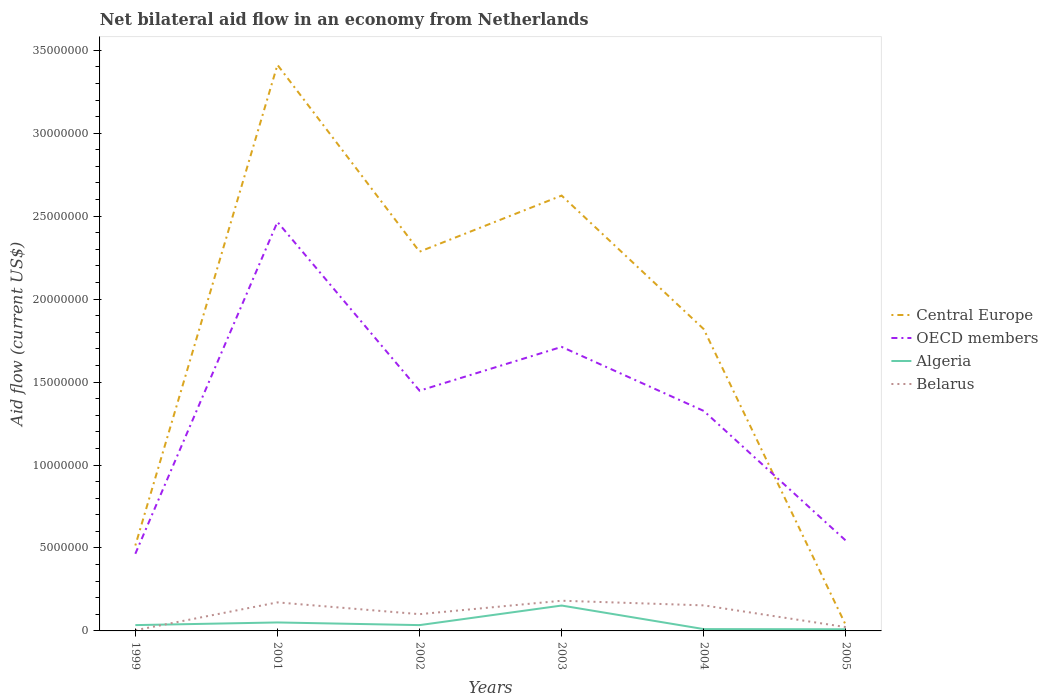How many different coloured lines are there?
Offer a terse response. 4. Does the line corresponding to Belarus intersect with the line corresponding to Algeria?
Ensure brevity in your answer.  Yes. What is the difference between the highest and the second highest net bilateral aid flow in OECD members?
Your answer should be very brief. 2.00e+07. What is the difference between the highest and the lowest net bilateral aid flow in Belarus?
Offer a very short reply. 3. How many lines are there?
Provide a short and direct response. 4. How many years are there in the graph?
Offer a terse response. 6. What is the difference between two consecutive major ticks on the Y-axis?
Offer a very short reply. 5.00e+06. Are the values on the major ticks of Y-axis written in scientific E-notation?
Make the answer very short. No. Does the graph contain any zero values?
Your response must be concise. No. Does the graph contain grids?
Your answer should be compact. No. How many legend labels are there?
Make the answer very short. 4. How are the legend labels stacked?
Keep it short and to the point. Vertical. What is the title of the graph?
Keep it short and to the point. Net bilateral aid flow in an economy from Netherlands. What is the Aid flow (current US$) in Central Europe in 1999?
Keep it short and to the point. 5.15e+06. What is the Aid flow (current US$) of OECD members in 1999?
Make the answer very short. 4.65e+06. What is the Aid flow (current US$) of Belarus in 1999?
Make the answer very short. 4.00e+04. What is the Aid flow (current US$) in Central Europe in 2001?
Your answer should be compact. 3.41e+07. What is the Aid flow (current US$) in OECD members in 2001?
Keep it short and to the point. 2.46e+07. What is the Aid flow (current US$) in Algeria in 2001?
Make the answer very short. 5.10e+05. What is the Aid flow (current US$) in Belarus in 2001?
Offer a terse response. 1.72e+06. What is the Aid flow (current US$) of Central Europe in 2002?
Offer a terse response. 2.29e+07. What is the Aid flow (current US$) in OECD members in 2002?
Your answer should be compact. 1.45e+07. What is the Aid flow (current US$) of Belarus in 2002?
Your answer should be compact. 1.01e+06. What is the Aid flow (current US$) of Central Europe in 2003?
Provide a short and direct response. 2.62e+07. What is the Aid flow (current US$) in OECD members in 2003?
Provide a succinct answer. 1.71e+07. What is the Aid flow (current US$) in Algeria in 2003?
Offer a terse response. 1.53e+06. What is the Aid flow (current US$) of Belarus in 2003?
Your answer should be compact. 1.82e+06. What is the Aid flow (current US$) in Central Europe in 2004?
Offer a very short reply. 1.82e+07. What is the Aid flow (current US$) in OECD members in 2004?
Offer a terse response. 1.33e+07. What is the Aid flow (current US$) of Belarus in 2004?
Ensure brevity in your answer.  1.54e+06. What is the Aid flow (current US$) in Central Europe in 2005?
Your answer should be compact. 3.40e+05. What is the Aid flow (current US$) of OECD members in 2005?
Your answer should be very brief. 5.44e+06. Across all years, what is the maximum Aid flow (current US$) in Central Europe?
Offer a very short reply. 3.41e+07. Across all years, what is the maximum Aid flow (current US$) in OECD members?
Offer a very short reply. 2.46e+07. Across all years, what is the maximum Aid flow (current US$) in Algeria?
Your response must be concise. 1.53e+06. Across all years, what is the maximum Aid flow (current US$) in Belarus?
Make the answer very short. 1.82e+06. Across all years, what is the minimum Aid flow (current US$) in OECD members?
Ensure brevity in your answer.  4.65e+06. Across all years, what is the minimum Aid flow (current US$) of Algeria?
Ensure brevity in your answer.  1.00e+05. Across all years, what is the minimum Aid flow (current US$) of Belarus?
Provide a succinct answer. 4.00e+04. What is the total Aid flow (current US$) in Central Europe in the graph?
Your response must be concise. 1.07e+08. What is the total Aid flow (current US$) of OECD members in the graph?
Offer a terse response. 7.96e+07. What is the total Aid flow (current US$) in Algeria in the graph?
Your answer should be compact. 2.95e+06. What is the total Aid flow (current US$) of Belarus in the graph?
Keep it short and to the point. 6.36e+06. What is the difference between the Aid flow (current US$) in Central Europe in 1999 and that in 2001?
Make the answer very short. -2.90e+07. What is the difference between the Aid flow (current US$) of OECD members in 1999 and that in 2001?
Offer a terse response. -2.00e+07. What is the difference between the Aid flow (current US$) of Belarus in 1999 and that in 2001?
Provide a short and direct response. -1.68e+06. What is the difference between the Aid flow (current US$) of Central Europe in 1999 and that in 2002?
Give a very brief answer. -1.77e+07. What is the difference between the Aid flow (current US$) in OECD members in 1999 and that in 2002?
Your response must be concise. -9.83e+06. What is the difference between the Aid flow (current US$) of Algeria in 1999 and that in 2002?
Your response must be concise. 0. What is the difference between the Aid flow (current US$) of Belarus in 1999 and that in 2002?
Provide a succinct answer. -9.70e+05. What is the difference between the Aid flow (current US$) in Central Europe in 1999 and that in 2003?
Give a very brief answer. -2.11e+07. What is the difference between the Aid flow (current US$) of OECD members in 1999 and that in 2003?
Give a very brief answer. -1.25e+07. What is the difference between the Aid flow (current US$) in Algeria in 1999 and that in 2003?
Your answer should be very brief. -1.18e+06. What is the difference between the Aid flow (current US$) in Belarus in 1999 and that in 2003?
Your answer should be compact. -1.78e+06. What is the difference between the Aid flow (current US$) of Central Europe in 1999 and that in 2004?
Give a very brief answer. -1.30e+07. What is the difference between the Aid flow (current US$) of OECD members in 1999 and that in 2004?
Make the answer very short. -8.61e+06. What is the difference between the Aid flow (current US$) of Algeria in 1999 and that in 2004?
Offer a terse response. 2.40e+05. What is the difference between the Aid flow (current US$) in Belarus in 1999 and that in 2004?
Provide a succinct answer. -1.50e+06. What is the difference between the Aid flow (current US$) in Central Europe in 1999 and that in 2005?
Your answer should be compact. 4.81e+06. What is the difference between the Aid flow (current US$) in OECD members in 1999 and that in 2005?
Ensure brevity in your answer.  -7.90e+05. What is the difference between the Aid flow (current US$) in Central Europe in 2001 and that in 2002?
Offer a terse response. 1.13e+07. What is the difference between the Aid flow (current US$) in OECD members in 2001 and that in 2002?
Your answer should be compact. 1.02e+07. What is the difference between the Aid flow (current US$) in Belarus in 2001 and that in 2002?
Your answer should be very brief. 7.10e+05. What is the difference between the Aid flow (current US$) in Central Europe in 2001 and that in 2003?
Provide a short and direct response. 7.88e+06. What is the difference between the Aid flow (current US$) in OECD members in 2001 and that in 2003?
Offer a very short reply. 7.53e+06. What is the difference between the Aid flow (current US$) of Algeria in 2001 and that in 2003?
Make the answer very short. -1.02e+06. What is the difference between the Aid flow (current US$) in Central Europe in 2001 and that in 2004?
Your answer should be compact. 1.59e+07. What is the difference between the Aid flow (current US$) in OECD members in 2001 and that in 2004?
Your answer should be compact. 1.14e+07. What is the difference between the Aid flow (current US$) of Algeria in 2001 and that in 2004?
Make the answer very short. 4.00e+05. What is the difference between the Aid flow (current US$) of Belarus in 2001 and that in 2004?
Your answer should be very brief. 1.80e+05. What is the difference between the Aid flow (current US$) in Central Europe in 2001 and that in 2005?
Offer a very short reply. 3.38e+07. What is the difference between the Aid flow (current US$) in OECD members in 2001 and that in 2005?
Offer a terse response. 1.92e+07. What is the difference between the Aid flow (current US$) of Algeria in 2001 and that in 2005?
Provide a short and direct response. 4.10e+05. What is the difference between the Aid flow (current US$) in Belarus in 2001 and that in 2005?
Give a very brief answer. 1.49e+06. What is the difference between the Aid flow (current US$) of Central Europe in 2002 and that in 2003?
Ensure brevity in your answer.  -3.38e+06. What is the difference between the Aid flow (current US$) of OECD members in 2002 and that in 2003?
Your answer should be very brief. -2.64e+06. What is the difference between the Aid flow (current US$) of Algeria in 2002 and that in 2003?
Your response must be concise. -1.18e+06. What is the difference between the Aid flow (current US$) of Belarus in 2002 and that in 2003?
Make the answer very short. -8.10e+05. What is the difference between the Aid flow (current US$) of Central Europe in 2002 and that in 2004?
Offer a terse response. 4.67e+06. What is the difference between the Aid flow (current US$) in OECD members in 2002 and that in 2004?
Give a very brief answer. 1.22e+06. What is the difference between the Aid flow (current US$) in Belarus in 2002 and that in 2004?
Your response must be concise. -5.30e+05. What is the difference between the Aid flow (current US$) in Central Europe in 2002 and that in 2005?
Give a very brief answer. 2.25e+07. What is the difference between the Aid flow (current US$) of OECD members in 2002 and that in 2005?
Ensure brevity in your answer.  9.04e+06. What is the difference between the Aid flow (current US$) in Belarus in 2002 and that in 2005?
Make the answer very short. 7.80e+05. What is the difference between the Aid flow (current US$) in Central Europe in 2003 and that in 2004?
Ensure brevity in your answer.  8.05e+06. What is the difference between the Aid flow (current US$) of OECD members in 2003 and that in 2004?
Ensure brevity in your answer.  3.86e+06. What is the difference between the Aid flow (current US$) of Algeria in 2003 and that in 2004?
Offer a terse response. 1.42e+06. What is the difference between the Aid flow (current US$) of Belarus in 2003 and that in 2004?
Offer a terse response. 2.80e+05. What is the difference between the Aid flow (current US$) of Central Europe in 2003 and that in 2005?
Keep it short and to the point. 2.59e+07. What is the difference between the Aid flow (current US$) of OECD members in 2003 and that in 2005?
Keep it short and to the point. 1.17e+07. What is the difference between the Aid flow (current US$) of Algeria in 2003 and that in 2005?
Ensure brevity in your answer.  1.43e+06. What is the difference between the Aid flow (current US$) of Belarus in 2003 and that in 2005?
Offer a terse response. 1.59e+06. What is the difference between the Aid flow (current US$) of Central Europe in 2004 and that in 2005?
Give a very brief answer. 1.78e+07. What is the difference between the Aid flow (current US$) of OECD members in 2004 and that in 2005?
Keep it short and to the point. 7.82e+06. What is the difference between the Aid flow (current US$) of Belarus in 2004 and that in 2005?
Offer a terse response. 1.31e+06. What is the difference between the Aid flow (current US$) of Central Europe in 1999 and the Aid flow (current US$) of OECD members in 2001?
Keep it short and to the point. -1.95e+07. What is the difference between the Aid flow (current US$) in Central Europe in 1999 and the Aid flow (current US$) in Algeria in 2001?
Your answer should be very brief. 4.64e+06. What is the difference between the Aid flow (current US$) in Central Europe in 1999 and the Aid flow (current US$) in Belarus in 2001?
Keep it short and to the point. 3.43e+06. What is the difference between the Aid flow (current US$) in OECD members in 1999 and the Aid flow (current US$) in Algeria in 2001?
Your response must be concise. 4.14e+06. What is the difference between the Aid flow (current US$) of OECD members in 1999 and the Aid flow (current US$) of Belarus in 2001?
Give a very brief answer. 2.93e+06. What is the difference between the Aid flow (current US$) of Algeria in 1999 and the Aid flow (current US$) of Belarus in 2001?
Offer a terse response. -1.37e+06. What is the difference between the Aid flow (current US$) in Central Europe in 1999 and the Aid flow (current US$) in OECD members in 2002?
Make the answer very short. -9.33e+06. What is the difference between the Aid flow (current US$) in Central Europe in 1999 and the Aid flow (current US$) in Algeria in 2002?
Offer a very short reply. 4.80e+06. What is the difference between the Aid flow (current US$) of Central Europe in 1999 and the Aid flow (current US$) of Belarus in 2002?
Offer a very short reply. 4.14e+06. What is the difference between the Aid flow (current US$) in OECD members in 1999 and the Aid flow (current US$) in Algeria in 2002?
Provide a short and direct response. 4.30e+06. What is the difference between the Aid flow (current US$) in OECD members in 1999 and the Aid flow (current US$) in Belarus in 2002?
Your response must be concise. 3.64e+06. What is the difference between the Aid flow (current US$) of Algeria in 1999 and the Aid flow (current US$) of Belarus in 2002?
Your response must be concise. -6.60e+05. What is the difference between the Aid flow (current US$) in Central Europe in 1999 and the Aid flow (current US$) in OECD members in 2003?
Give a very brief answer. -1.20e+07. What is the difference between the Aid flow (current US$) in Central Europe in 1999 and the Aid flow (current US$) in Algeria in 2003?
Offer a terse response. 3.62e+06. What is the difference between the Aid flow (current US$) of Central Europe in 1999 and the Aid flow (current US$) of Belarus in 2003?
Give a very brief answer. 3.33e+06. What is the difference between the Aid flow (current US$) of OECD members in 1999 and the Aid flow (current US$) of Algeria in 2003?
Offer a very short reply. 3.12e+06. What is the difference between the Aid flow (current US$) in OECD members in 1999 and the Aid flow (current US$) in Belarus in 2003?
Provide a succinct answer. 2.83e+06. What is the difference between the Aid flow (current US$) of Algeria in 1999 and the Aid flow (current US$) of Belarus in 2003?
Keep it short and to the point. -1.47e+06. What is the difference between the Aid flow (current US$) in Central Europe in 1999 and the Aid flow (current US$) in OECD members in 2004?
Keep it short and to the point. -8.11e+06. What is the difference between the Aid flow (current US$) of Central Europe in 1999 and the Aid flow (current US$) of Algeria in 2004?
Ensure brevity in your answer.  5.04e+06. What is the difference between the Aid flow (current US$) in Central Europe in 1999 and the Aid flow (current US$) in Belarus in 2004?
Make the answer very short. 3.61e+06. What is the difference between the Aid flow (current US$) of OECD members in 1999 and the Aid flow (current US$) of Algeria in 2004?
Provide a succinct answer. 4.54e+06. What is the difference between the Aid flow (current US$) in OECD members in 1999 and the Aid flow (current US$) in Belarus in 2004?
Give a very brief answer. 3.11e+06. What is the difference between the Aid flow (current US$) of Algeria in 1999 and the Aid flow (current US$) of Belarus in 2004?
Your answer should be very brief. -1.19e+06. What is the difference between the Aid flow (current US$) of Central Europe in 1999 and the Aid flow (current US$) of Algeria in 2005?
Provide a succinct answer. 5.05e+06. What is the difference between the Aid flow (current US$) of Central Europe in 1999 and the Aid flow (current US$) of Belarus in 2005?
Provide a short and direct response. 4.92e+06. What is the difference between the Aid flow (current US$) in OECD members in 1999 and the Aid flow (current US$) in Algeria in 2005?
Provide a short and direct response. 4.55e+06. What is the difference between the Aid flow (current US$) of OECD members in 1999 and the Aid flow (current US$) of Belarus in 2005?
Make the answer very short. 4.42e+06. What is the difference between the Aid flow (current US$) of Central Europe in 2001 and the Aid flow (current US$) of OECD members in 2002?
Offer a very short reply. 1.96e+07. What is the difference between the Aid flow (current US$) of Central Europe in 2001 and the Aid flow (current US$) of Algeria in 2002?
Your response must be concise. 3.38e+07. What is the difference between the Aid flow (current US$) in Central Europe in 2001 and the Aid flow (current US$) in Belarus in 2002?
Your response must be concise. 3.31e+07. What is the difference between the Aid flow (current US$) in OECD members in 2001 and the Aid flow (current US$) in Algeria in 2002?
Offer a very short reply. 2.43e+07. What is the difference between the Aid flow (current US$) of OECD members in 2001 and the Aid flow (current US$) of Belarus in 2002?
Give a very brief answer. 2.36e+07. What is the difference between the Aid flow (current US$) in Algeria in 2001 and the Aid flow (current US$) in Belarus in 2002?
Your response must be concise. -5.00e+05. What is the difference between the Aid flow (current US$) in Central Europe in 2001 and the Aid flow (current US$) in OECD members in 2003?
Your answer should be very brief. 1.70e+07. What is the difference between the Aid flow (current US$) of Central Europe in 2001 and the Aid flow (current US$) of Algeria in 2003?
Provide a succinct answer. 3.26e+07. What is the difference between the Aid flow (current US$) of Central Europe in 2001 and the Aid flow (current US$) of Belarus in 2003?
Ensure brevity in your answer.  3.23e+07. What is the difference between the Aid flow (current US$) of OECD members in 2001 and the Aid flow (current US$) of Algeria in 2003?
Your answer should be very brief. 2.31e+07. What is the difference between the Aid flow (current US$) in OECD members in 2001 and the Aid flow (current US$) in Belarus in 2003?
Your answer should be compact. 2.28e+07. What is the difference between the Aid flow (current US$) of Algeria in 2001 and the Aid flow (current US$) of Belarus in 2003?
Your answer should be very brief. -1.31e+06. What is the difference between the Aid flow (current US$) of Central Europe in 2001 and the Aid flow (current US$) of OECD members in 2004?
Provide a succinct answer. 2.09e+07. What is the difference between the Aid flow (current US$) of Central Europe in 2001 and the Aid flow (current US$) of Algeria in 2004?
Offer a very short reply. 3.40e+07. What is the difference between the Aid flow (current US$) in Central Europe in 2001 and the Aid flow (current US$) in Belarus in 2004?
Provide a short and direct response. 3.26e+07. What is the difference between the Aid flow (current US$) of OECD members in 2001 and the Aid flow (current US$) of Algeria in 2004?
Offer a terse response. 2.45e+07. What is the difference between the Aid flow (current US$) in OECD members in 2001 and the Aid flow (current US$) in Belarus in 2004?
Ensure brevity in your answer.  2.31e+07. What is the difference between the Aid flow (current US$) of Algeria in 2001 and the Aid flow (current US$) of Belarus in 2004?
Your response must be concise. -1.03e+06. What is the difference between the Aid flow (current US$) of Central Europe in 2001 and the Aid flow (current US$) of OECD members in 2005?
Your response must be concise. 2.87e+07. What is the difference between the Aid flow (current US$) of Central Europe in 2001 and the Aid flow (current US$) of Algeria in 2005?
Your response must be concise. 3.40e+07. What is the difference between the Aid flow (current US$) in Central Europe in 2001 and the Aid flow (current US$) in Belarus in 2005?
Your response must be concise. 3.39e+07. What is the difference between the Aid flow (current US$) in OECD members in 2001 and the Aid flow (current US$) in Algeria in 2005?
Offer a terse response. 2.46e+07. What is the difference between the Aid flow (current US$) in OECD members in 2001 and the Aid flow (current US$) in Belarus in 2005?
Ensure brevity in your answer.  2.44e+07. What is the difference between the Aid flow (current US$) of Algeria in 2001 and the Aid flow (current US$) of Belarus in 2005?
Make the answer very short. 2.80e+05. What is the difference between the Aid flow (current US$) in Central Europe in 2002 and the Aid flow (current US$) in OECD members in 2003?
Your answer should be compact. 5.74e+06. What is the difference between the Aid flow (current US$) of Central Europe in 2002 and the Aid flow (current US$) of Algeria in 2003?
Your answer should be compact. 2.13e+07. What is the difference between the Aid flow (current US$) in Central Europe in 2002 and the Aid flow (current US$) in Belarus in 2003?
Give a very brief answer. 2.10e+07. What is the difference between the Aid flow (current US$) of OECD members in 2002 and the Aid flow (current US$) of Algeria in 2003?
Make the answer very short. 1.30e+07. What is the difference between the Aid flow (current US$) of OECD members in 2002 and the Aid flow (current US$) of Belarus in 2003?
Your response must be concise. 1.27e+07. What is the difference between the Aid flow (current US$) of Algeria in 2002 and the Aid flow (current US$) of Belarus in 2003?
Provide a short and direct response. -1.47e+06. What is the difference between the Aid flow (current US$) in Central Europe in 2002 and the Aid flow (current US$) in OECD members in 2004?
Ensure brevity in your answer.  9.60e+06. What is the difference between the Aid flow (current US$) in Central Europe in 2002 and the Aid flow (current US$) in Algeria in 2004?
Your answer should be very brief. 2.28e+07. What is the difference between the Aid flow (current US$) of Central Europe in 2002 and the Aid flow (current US$) of Belarus in 2004?
Your response must be concise. 2.13e+07. What is the difference between the Aid flow (current US$) in OECD members in 2002 and the Aid flow (current US$) in Algeria in 2004?
Keep it short and to the point. 1.44e+07. What is the difference between the Aid flow (current US$) of OECD members in 2002 and the Aid flow (current US$) of Belarus in 2004?
Make the answer very short. 1.29e+07. What is the difference between the Aid flow (current US$) in Algeria in 2002 and the Aid flow (current US$) in Belarus in 2004?
Your answer should be compact. -1.19e+06. What is the difference between the Aid flow (current US$) of Central Europe in 2002 and the Aid flow (current US$) of OECD members in 2005?
Ensure brevity in your answer.  1.74e+07. What is the difference between the Aid flow (current US$) of Central Europe in 2002 and the Aid flow (current US$) of Algeria in 2005?
Make the answer very short. 2.28e+07. What is the difference between the Aid flow (current US$) of Central Europe in 2002 and the Aid flow (current US$) of Belarus in 2005?
Make the answer very short. 2.26e+07. What is the difference between the Aid flow (current US$) of OECD members in 2002 and the Aid flow (current US$) of Algeria in 2005?
Your response must be concise. 1.44e+07. What is the difference between the Aid flow (current US$) in OECD members in 2002 and the Aid flow (current US$) in Belarus in 2005?
Keep it short and to the point. 1.42e+07. What is the difference between the Aid flow (current US$) in Algeria in 2002 and the Aid flow (current US$) in Belarus in 2005?
Your response must be concise. 1.20e+05. What is the difference between the Aid flow (current US$) in Central Europe in 2003 and the Aid flow (current US$) in OECD members in 2004?
Offer a very short reply. 1.30e+07. What is the difference between the Aid flow (current US$) in Central Europe in 2003 and the Aid flow (current US$) in Algeria in 2004?
Keep it short and to the point. 2.61e+07. What is the difference between the Aid flow (current US$) of Central Europe in 2003 and the Aid flow (current US$) of Belarus in 2004?
Provide a succinct answer. 2.47e+07. What is the difference between the Aid flow (current US$) of OECD members in 2003 and the Aid flow (current US$) of Algeria in 2004?
Your response must be concise. 1.70e+07. What is the difference between the Aid flow (current US$) of OECD members in 2003 and the Aid flow (current US$) of Belarus in 2004?
Offer a very short reply. 1.56e+07. What is the difference between the Aid flow (current US$) of Algeria in 2003 and the Aid flow (current US$) of Belarus in 2004?
Your answer should be compact. -10000. What is the difference between the Aid flow (current US$) of Central Europe in 2003 and the Aid flow (current US$) of OECD members in 2005?
Your response must be concise. 2.08e+07. What is the difference between the Aid flow (current US$) in Central Europe in 2003 and the Aid flow (current US$) in Algeria in 2005?
Keep it short and to the point. 2.61e+07. What is the difference between the Aid flow (current US$) in Central Europe in 2003 and the Aid flow (current US$) in Belarus in 2005?
Your answer should be compact. 2.60e+07. What is the difference between the Aid flow (current US$) in OECD members in 2003 and the Aid flow (current US$) in Algeria in 2005?
Offer a very short reply. 1.70e+07. What is the difference between the Aid flow (current US$) of OECD members in 2003 and the Aid flow (current US$) of Belarus in 2005?
Your response must be concise. 1.69e+07. What is the difference between the Aid flow (current US$) of Algeria in 2003 and the Aid flow (current US$) of Belarus in 2005?
Make the answer very short. 1.30e+06. What is the difference between the Aid flow (current US$) in Central Europe in 2004 and the Aid flow (current US$) in OECD members in 2005?
Keep it short and to the point. 1.28e+07. What is the difference between the Aid flow (current US$) of Central Europe in 2004 and the Aid flow (current US$) of Algeria in 2005?
Keep it short and to the point. 1.81e+07. What is the difference between the Aid flow (current US$) in Central Europe in 2004 and the Aid flow (current US$) in Belarus in 2005?
Provide a succinct answer. 1.80e+07. What is the difference between the Aid flow (current US$) of OECD members in 2004 and the Aid flow (current US$) of Algeria in 2005?
Make the answer very short. 1.32e+07. What is the difference between the Aid flow (current US$) of OECD members in 2004 and the Aid flow (current US$) of Belarus in 2005?
Provide a succinct answer. 1.30e+07. What is the difference between the Aid flow (current US$) of Algeria in 2004 and the Aid flow (current US$) of Belarus in 2005?
Offer a terse response. -1.20e+05. What is the average Aid flow (current US$) in Central Europe per year?
Offer a terse response. 1.78e+07. What is the average Aid flow (current US$) in OECD members per year?
Ensure brevity in your answer.  1.33e+07. What is the average Aid flow (current US$) in Algeria per year?
Keep it short and to the point. 4.92e+05. What is the average Aid flow (current US$) of Belarus per year?
Ensure brevity in your answer.  1.06e+06. In the year 1999, what is the difference between the Aid flow (current US$) in Central Europe and Aid flow (current US$) in Algeria?
Ensure brevity in your answer.  4.80e+06. In the year 1999, what is the difference between the Aid flow (current US$) in Central Europe and Aid flow (current US$) in Belarus?
Give a very brief answer. 5.11e+06. In the year 1999, what is the difference between the Aid flow (current US$) in OECD members and Aid flow (current US$) in Algeria?
Your answer should be very brief. 4.30e+06. In the year 1999, what is the difference between the Aid flow (current US$) of OECD members and Aid flow (current US$) of Belarus?
Ensure brevity in your answer.  4.61e+06. In the year 1999, what is the difference between the Aid flow (current US$) of Algeria and Aid flow (current US$) of Belarus?
Offer a terse response. 3.10e+05. In the year 2001, what is the difference between the Aid flow (current US$) of Central Europe and Aid flow (current US$) of OECD members?
Your answer should be compact. 9.47e+06. In the year 2001, what is the difference between the Aid flow (current US$) in Central Europe and Aid flow (current US$) in Algeria?
Your answer should be very brief. 3.36e+07. In the year 2001, what is the difference between the Aid flow (current US$) of Central Europe and Aid flow (current US$) of Belarus?
Offer a very short reply. 3.24e+07. In the year 2001, what is the difference between the Aid flow (current US$) of OECD members and Aid flow (current US$) of Algeria?
Your answer should be compact. 2.41e+07. In the year 2001, what is the difference between the Aid flow (current US$) in OECD members and Aid flow (current US$) in Belarus?
Give a very brief answer. 2.29e+07. In the year 2001, what is the difference between the Aid flow (current US$) in Algeria and Aid flow (current US$) in Belarus?
Your response must be concise. -1.21e+06. In the year 2002, what is the difference between the Aid flow (current US$) of Central Europe and Aid flow (current US$) of OECD members?
Make the answer very short. 8.38e+06. In the year 2002, what is the difference between the Aid flow (current US$) in Central Europe and Aid flow (current US$) in Algeria?
Keep it short and to the point. 2.25e+07. In the year 2002, what is the difference between the Aid flow (current US$) of Central Europe and Aid flow (current US$) of Belarus?
Your answer should be compact. 2.18e+07. In the year 2002, what is the difference between the Aid flow (current US$) of OECD members and Aid flow (current US$) of Algeria?
Ensure brevity in your answer.  1.41e+07. In the year 2002, what is the difference between the Aid flow (current US$) in OECD members and Aid flow (current US$) in Belarus?
Keep it short and to the point. 1.35e+07. In the year 2002, what is the difference between the Aid flow (current US$) in Algeria and Aid flow (current US$) in Belarus?
Your answer should be compact. -6.60e+05. In the year 2003, what is the difference between the Aid flow (current US$) of Central Europe and Aid flow (current US$) of OECD members?
Give a very brief answer. 9.12e+06. In the year 2003, what is the difference between the Aid flow (current US$) of Central Europe and Aid flow (current US$) of Algeria?
Offer a terse response. 2.47e+07. In the year 2003, what is the difference between the Aid flow (current US$) of Central Europe and Aid flow (current US$) of Belarus?
Offer a very short reply. 2.44e+07. In the year 2003, what is the difference between the Aid flow (current US$) in OECD members and Aid flow (current US$) in Algeria?
Your response must be concise. 1.56e+07. In the year 2003, what is the difference between the Aid flow (current US$) of OECD members and Aid flow (current US$) of Belarus?
Give a very brief answer. 1.53e+07. In the year 2004, what is the difference between the Aid flow (current US$) in Central Europe and Aid flow (current US$) in OECD members?
Ensure brevity in your answer.  4.93e+06. In the year 2004, what is the difference between the Aid flow (current US$) of Central Europe and Aid flow (current US$) of Algeria?
Make the answer very short. 1.81e+07. In the year 2004, what is the difference between the Aid flow (current US$) in Central Europe and Aid flow (current US$) in Belarus?
Your response must be concise. 1.66e+07. In the year 2004, what is the difference between the Aid flow (current US$) of OECD members and Aid flow (current US$) of Algeria?
Your answer should be very brief. 1.32e+07. In the year 2004, what is the difference between the Aid flow (current US$) in OECD members and Aid flow (current US$) in Belarus?
Keep it short and to the point. 1.17e+07. In the year 2004, what is the difference between the Aid flow (current US$) in Algeria and Aid flow (current US$) in Belarus?
Give a very brief answer. -1.43e+06. In the year 2005, what is the difference between the Aid flow (current US$) in Central Europe and Aid flow (current US$) in OECD members?
Your answer should be very brief. -5.10e+06. In the year 2005, what is the difference between the Aid flow (current US$) in Central Europe and Aid flow (current US$) in Algeria?
Offer a terse response. 2.40e+05. In the year 2005, what is the difference between the Aid flow (current US$) of Central Europe and Aid flow (current US$) of Belarus?
Your response must be concise. 1.10e+05. In the year 2005, what is the difference between the Aid flow (current US$) of OECD members and Aid flow (current US$) of Algeria?
Give a very brief answer. 5.34e+06. In the year 2005, what is the difference between the Aid flow (current US$) of OECD members and Aid flow (current US$) of Belarus?
Provide a short and direct response. 5.21e+06. What is the ratio of the Aid flow (current US$) in Central Europe in 1999 to that in 2001?
Provide a succinct answer. 0.15. What is the ratio of the Aid flow (current US$) in OECD members in 1999 to that in 2001?
Make the answer very short. 0.19. What is the ratio of the Aid flow (current US$) in Algeria in 1999 to that in 2001?
Your answer should be compact. 0.69. What is the ratio of the Aid flow (current US$) in Belarus in 1999 to that in 2001?
Provide a succinct answer. 0.02. What is the ratio of the Aid flow (current US$) in Central Europe in 1999 to that in 2002?
Ensure brevity in your answer.  0.23. What is the ratio of the Aid flow (current US$) in OECD members in 1999 to that in 2002?
Make the answer very short. 0.32. What is the ratio of the Aid flow (current US$) of Belarus in 1999 to that in 2002?
Give a very brief answer. 0.04. What is the ratio of the Aid flow (current US$) of Central Europe in 1999 to that in 2003?
Offer a terse response. 0.2. What is the ratio of the Aid flow (current US$) of OECD members in 1999 to that in 2003?
Your answer should be compact. 0.27. What is the ratio of the Aid flow (current US$) of Algeria in 1999 to that in 2003?
Ensure brevity in your answer.  0.23. What is the ratio of the Aid flow (current US$) in Belarus in 1999 to that in 2003?
Offer a very short reply. 0.02. What is the ratio of the Aid flow (current US$) of Central Europe in 1999 to that in 2004?
Your answer should be very brief. 0.28. What is the ratio of the Aid flow (current US$) in OECD members in 1999 to that in 2004?
Provide a succinct answer. 0.35. What is the ratio of the Aid flow (current US$) in Algeria in 1999 to that in 2004?
Your answer should be compact. 3.18. What is the ratio of the Aid flow (current US$) in Belarus in 1999 to that in 2004?
Give a very brief answer. 0.03. What is the ratio of the Aid flow (current US$) of Central Europe in 1999 to that in 2005?
Provide a succinct answer. 15.15. What is the ratio of the Aid flow (current US$) of OECD members in 1999 to that in 2005?
Your response must be concise. 0.85. What is the ratio of the Aid flow (current US$) in Belarus in 1999 to that in 2005?
Offer a very short reply. 0.17. What is the ratio of the Aid flow (current US$) in Central Europe in 2001 to that in 2002?
Ensure brevity in your answer.  1.49. What is the ratio of the Aid flow (current US$) in OECD members in 2001 to that in 2002?
Keep it short and to the point. 1.7. What is the ratio of the Aid flow (current US$) in Algeria in 2001 to that in 2002?
Offer a terse response. 1.46. What is the ratio of the Aid flow (current US$) of Belarus in 2001 to that in 2002?
Ensure brevity in your answer.  1.7. What is the ratio of the Aid flow (current US$) in Central Europe in 2001 to that in 2003?
Your answer should be very brief. 1.3. What is the ratio of the Aid flow (current US$) of OECD members in 2001 to that in 2003?
Offer a very short reply. 1.44. What is the ratio of the Aid flow (current US$) of Algeria in 2001 to that in 2003?
Keep it short and to the point. 0.33. What is the ratio of the Aid flow (current US$) of Belarus in 2001 to that in 2003?
Offer a terse response. 0.95. What is the ratio of the Aid flow (current US$) in Central Europe in 2001 to that in 2004?
Provide a succinct answer. 1.88. What is the ratio of the Aid flow (current US$) of OECD members in 2001 to that in 2004?
Provide a succinct answer. 1.86. What is the ratio of the Aid flow (current US$) in Algeria in 2001 to that in 2004?
Provide a short and direct response. 4.64. What is the ratio of the Aid flow (current US$) in Belarus in 2001 to that in 2004?
Your response must be concise. 1.12. What is the ratio of the Aid flow (current US$) of Central Europe in 2001 to that in 2005?
Make the answer very short. 100.35. What is the ratio of the Aid flow (current US$) in OECD members in 2001 to that in 2005?
Ensure brevity in your answer.  4.53. What is the ratio of the Aid flow (current US$) in Belarus in 2001 to that in 2005?
Make the answer very short. 7.48. What is the ratio of the Aid flow (current US$) of Central Europe in 2002 to that in 2003?
Make the answer very short. 0.87. What is the ratio of the Aid flow (current US$) of OECD members in 2002 to that in 2003?
Make the answer very short. 0.85. What is the ratio of the Aid flow (current US$) of Algeria in 2002 to that in 2003?
Provide a short and direct response. 0.23. What is the ratio of the Aid flow (current US$) in Belarus in 2002 to that in 2003?
Offer a terse response. 0.55. What is the ratio of the Aid flow (current US$) of Central Europe in 2002 to that in 2004?
Your answer should be very brief. 1.26. What is the ratio of the Aid flow (current US$) in OECD members in 2002 to that in 2004?
Give a very brief answer. 1.09. What is the ratio of the Aid flow (current US$) of Algeria in 2002 to that in 2004?
Provide a succinct answer. 3.18. What is the ratio of the Aid flow (current US$) in Belarus in 2002 to that in 2004?
Offer a terse response. 0.66. What is the ratio of the Aid flow (current US$) of Central Europe in 2002 to that in 2005?
Keep it short and to the point. 67.24. What is the ratio of the Aid flow (current US$) of OECD members in 2002 to that in 2005?
Give a very brief answer. 2.66. What is the ratio of the Aid flow (current US$) of Belarus in 2002 to that in 2005?
Make the answer very short. 4.39. What is the ratio of the Aid flow (current US$) in Central Europe in 2003 to that in 2004?
Offer a terse response. 1.44. What is the ratio of the Aid flow (current US$) in OECD members in 2003 to that in 2004?
Provide a succinct answer. 1.29. What is the ratio of the Aid flow (current US$) of Algeria in 2003 to that in 2004?
Your answer should be compact. 13.91. What is the ratio of the Aid flow (current US$) of Belarus in 2003 to that in 2004?
Give a very brief answer. 1.18. What is the ratio of the Aid flow (current US$) of Central Europe in 2003 to that in 2005?
Offer a very short reply. 77.18. What is the ratio of the Aid flow (current US$) in OECD members in 2003 to that in 2005?
Give a very brief answer. 3.15. What is the ratio of the Aid flow (current US$) in Belarus in 2003 to that in 2005?
Provide a short and direct response. 7.91. What is the ratio of the Aid flow (current US$) of Central Europe in 2004 to that in 2005?
Your response must be concise. 53.5. What is the ratio of the Aid flow (current US$) of OECD members in 2004 to that in 2005?
Offer a terse response. 2.44. What is the ratio of the Aid flow (current US$) of Algeria in 2004 to that in 2005?
Offer a terse response. 1.1. What is the ratio of the Aid flow (current US$) in Belarus in 2004 to that in 2005?
Your answer should be compact. 6.7. What is the difference between the highest and the second highest Aid flow (current US$) of Central Europe?
Ensure brevity in your answer.  7.88e+06. What is the difference between the highest and the second highest Aid flow (current US$) of OECD members?
Offer a terse response. 7.53e+06. What is the difference between the highest and the second highest Aid flow (current US$) in Algeria?
Your answer should be compact. 1.02e+06. What is the difference between the highest and the second highest Aid flow (current US$) in Belarus?
Give a very brief answer. 1.00e+05. What is the difference between the highest and the lowest Aid flow (current US$) of Central Europe?
Give a very brief answer. 3.38e+07. What is the difference between the highest and the lowest Aid flow (current US$) in Algeria?
Your answer should be compact. 1.43e+06. What is the difference between the highest and the lowest Aid flow (current US$) of Belarus?
Make the answer very short. 1.78e+06. 